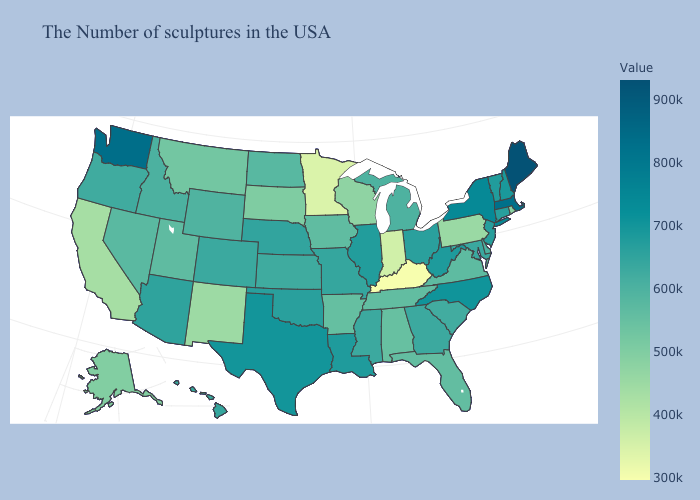Which states have the highest value in the USA?
Quick response, please. Maine. Does the map have missing data?
Be succinct. No. Among the states that border South Carolina , does North Carolina have the lowest value?
Write a very short answer. No. Which states hav the highest value in the South?
Keep it brief. North Carolina. Among the states that border Washington , which have the lowest value?
Be succinct. Idaho. 